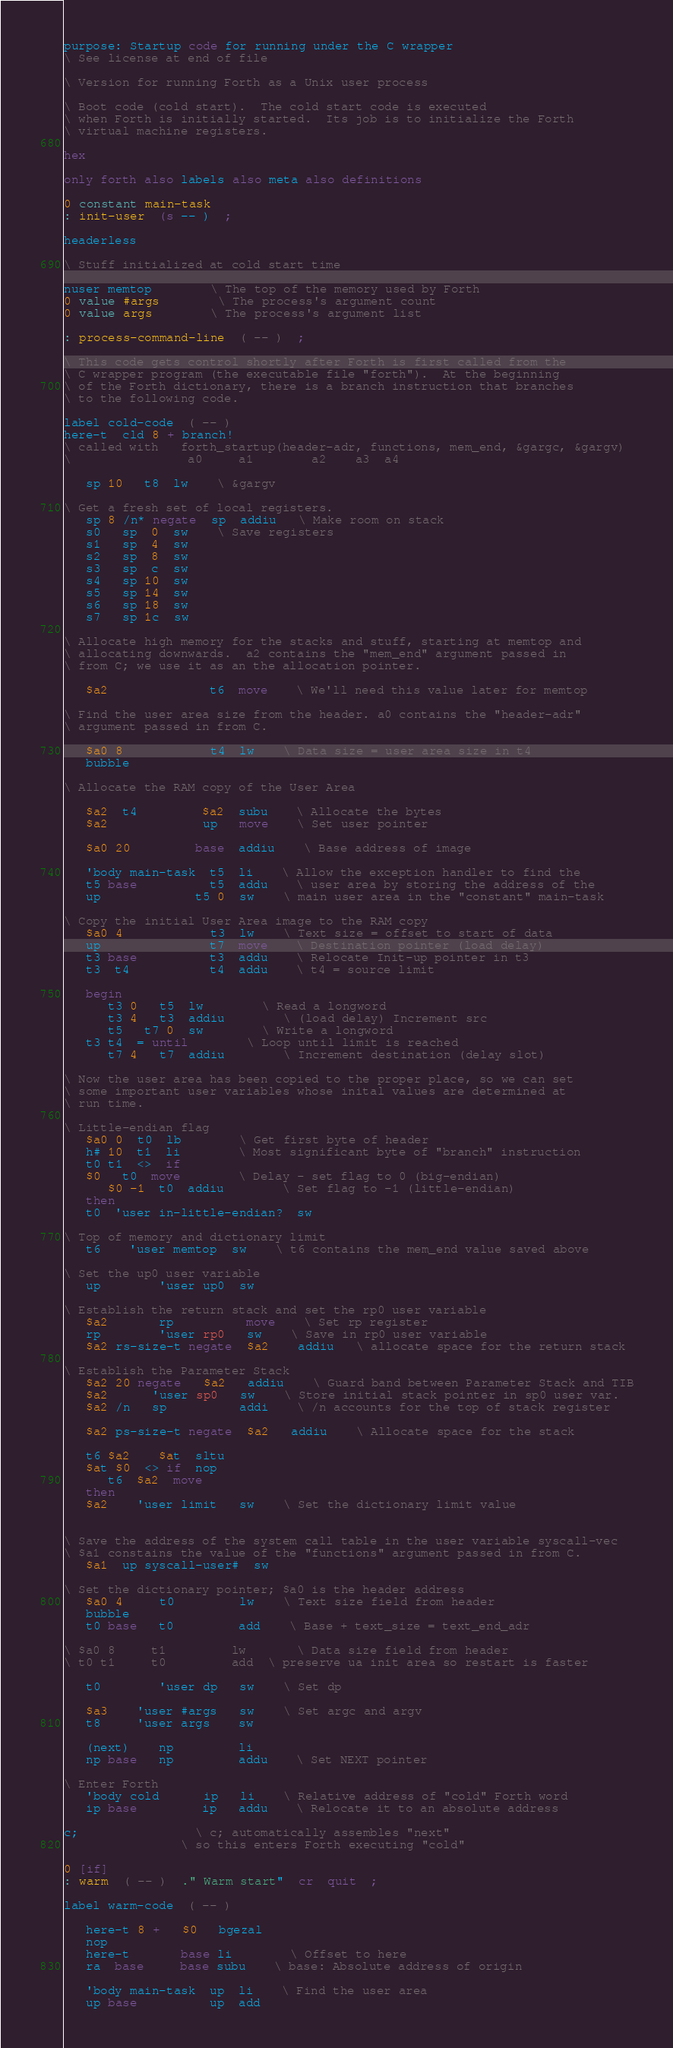Convert code to text. <code><loc_0><loc_0><loc_500><loc_500><_Forth_>purpose: Startup code for running under the C wrapper
\ See license at end of file

\ Version for running Forth as a Unix user process

\ Boot code (cold start).  The cold start code is executed
\ when Forth is initially started.  Its job is to initialize the Forth
\ virtual machine registers.

hex

only forth also labels also meta also definitions

0 constant main-task
: init-user  (s -- )  ;

headerless

\ Stuff initialized at cold start time

nuser memtop		\ The top of the memory used by Forth
0 value #args		\ The process's argument count
0 value args		\ The process's argument list

: process-command-line  ( -- )  ;

\ This code gets control shortly after Forth is first called from the
\ C wrapper program (the executable file "forth").  At the beginning
\ of the Forth dictionary, there is a branch instruction that branches
\ to the following code. 

label cold-code  ( -- )
here-t  cld 8 + branch!
\ called with   forth_startup(header-adr, functions, mem_end, &gargc, &gargv)
\ 				 a0	    a1	      a2	a3	a4

   sp 10   t8  lw	\ &gargv

\ Get a fresh set of local registers.
   sp 8 /n* negate  sp  addiu   \ Make room on stack
   s0   sp  0  sw	\ Save registers
   s1   sp  4  sw
   s2   sp  8  sw
   s3   sp  c  sw
   s4   sp 10  sw
   s5   sp 14  sw
   s6   sp 18  sw
   s7   sp 1c  sw

\ Allocate high memory for the stacks and stuff, starting at memtop and
\ allocating downwards.  a2 contains the "mem_end" argument passed in
\ from C; we use it as an the allocation pointer.

   $a2              t6  move	\ We'll need this value later for memtop

\ Find the user area size from the header. a0 contains the "header-adr"
\ argument passed in from C.

   $a0 8            t4  lw	\ Data size = user area size in t4
   bubble

\ Allocate the RAM copy of the User Area

   $a2  t4         $a2  subu	\ Allocate the bytes
   $a2             up   move	\ Set user pointer

   $a0 20         base  addiu	\ Base address of image

   'body main-task  t5  li	\ Allow the exception handler to find the
   t5 base          t5  addu	\ user area by storing the address of the
   up             t5 0  sw	\ main user area in the "constant" main-task

\ Copy the initial User Area image to the RAM copy
   $a0 4            t3  lw	\ Text size = offset to start of data
   up               t7  move	\ Destination pointer (load delay)
   t3 base          t3  addu	\ Relocate Init-up pointer in t3
   t3  t4           t4  addu	\ t4 = source limit

   begin
      t3 0   t5  lw		\ Read a longword
      t3 4   t3  addiu		\ (load delay) Increment src
      t5   t7 0  sw		\ Write a longword
   t3 t4  = until		\ Loop until limit is reached
      t7 4   t7  addiu		\ Increment destination (delay slot)

\ Now the user area has been copied to the proper place, so we can set
\ some important user variables whose inital values are determined at
\ run time.

\ Little-endian flag
   $a0 0  t0  lb		\ Get first byte of header
   h# 10  t1  li		\ Most significant byte of "branch" instruction
   t0 t1  <>  if
   $0   t0  move		\ Delay - set flag to 0 (big-endian)
      $0 -1  t0  addiu		\ Set flag to -1 (little-endian)
   then
   t0  'user in-little-endian?  sw

\ Top of memory and dictionary limit
   t6    'user memtop  sw	\ t6 contains the mem_end value saved above

\ Set the up0 user variable
   up        'user up0  sw

\ Establish the return stack and set the rp0 user variable
   $a2       rp          move	\ Set rp register
   rp        'user rp0   sw	\ Save in rp0 user variable
   $a2 rs-size-t negate  $a2    addiu   \ allocate space for the return stack

\ Establish the Parameter Stack
   $a2 20 negate   $a2   addiu	\ Guard band between Parameter Stack and TIB
   $a2      'user sp0   sw	\ Store initial stack pointer in sp0 user var.
   $a2 /n   sp          addi	\ /n accounts for the top of stack register

   $a2 ps-size-t negate  $a2   addiu	\ Allocate space for the stack

   t6 $a2    $at  sltu
   $at $0  <> if  nop
      t6  $a2  move
   then
   $a2    'user limit   sw	\ Set the dictionary limit value


\ Save the address of the system call table in the user variable syscall-vec
\ $a1 constains the value of the "functions" argument passed in from C.
   $a1  up syscall-user#  sw

\ Set the dictionary pointer; $a0 is the header address
   $a0 4     t0         lw	\ Text size field from header
   bubble
   t0 base   t0         add	\ Base + text_size = text_end_adr

\ $a0 8     t1         lw		\ Data size field from header
\ t0 t1     t0         add	\ preserve ua init area so restart is faster

   t0        'user dp   sw	\ Set dp

   $a3    'user #args   sw	\ Set argc and argv
   t8     'user args    sw

   (next)    np         li
   np base   np         addu	\ Set NEXT pointer

\ Enter Forth
   'body cold      ip   li	\ Relative address of "cold" Forth word
   ip base         ip   addu	\ Relocate it to an absolute address

c;				\ c; automatically assembles "next"
				\ so this enters Forth executing "cold"

0 [if]
: warm  ( -- )  ." Warm start"  cr  quit  ;

label warm-code  ( -- )

   here-t 8 +   $0   bgezal
   nop
   here-t       base li		\ Offset to here
   ra  base     base subu	\ base: Absolute address of origin

   'body main-task  up  li	\ Find the user area
   up base          up  add</code> 